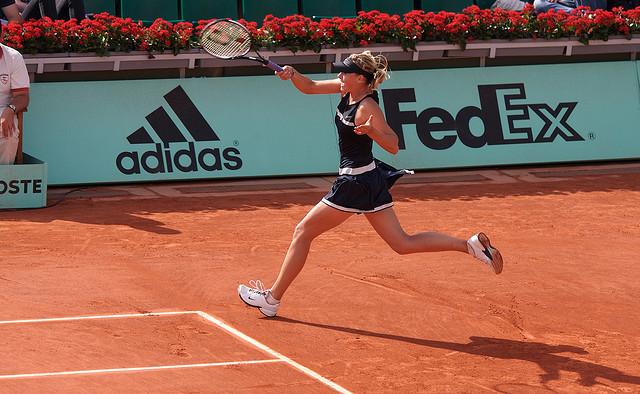What is she holding?
Concise answer only. Tennis racket. Is the woman flying?
Be succinct. No. Has anyone has a red shirt on?
Give a very brief answer. No. Why is she running?
Quick response, please. Playing tennis. Is the court blue?
Give a very brief answer. No. What color are the flowers?
Give a very brief answer. Red. Who is the shoe sponsor?
Keep it brief. Adidas. 